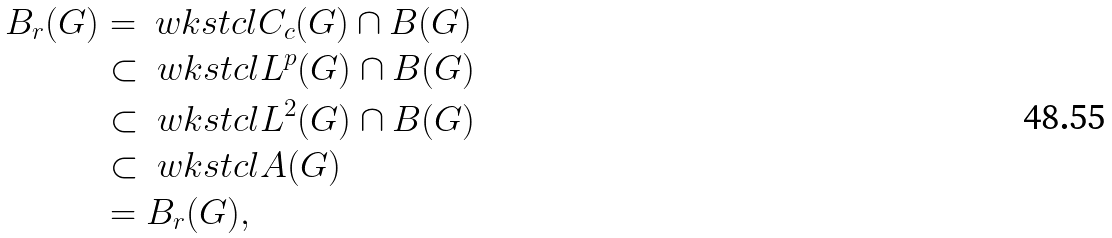<formula> <loc_0><loc_0><loc_500><loc_500>B _ { r } ( G ) & = \ w k s t c l { C _ { c } ( G ) \cap B ( G ) } \\ & \subset \ w k s t c l { L ^ { p } ( G ) \cap B ( G ) } \\ & \subset \ w k s t c l { L ^ { 2 } ( G ) \cap B ( G ) } \\ & \subset \ w k s t c l { A ( G ) } \\ & = B _ { r } ( G ) ,</formula> 